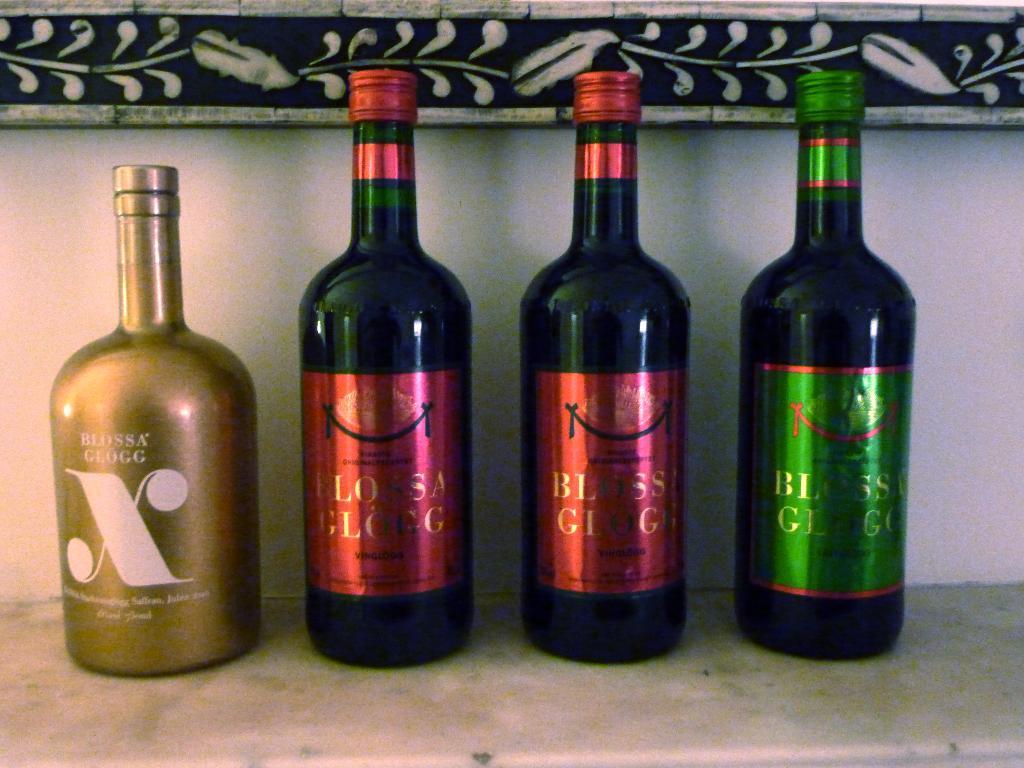What brand of drink do these bottles belong to?
Offer a very short reply. Blossa glogg. What is the name of the beverage on the left?
Offer a very short reply. Blossa glogg. 